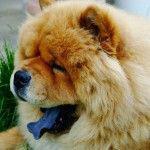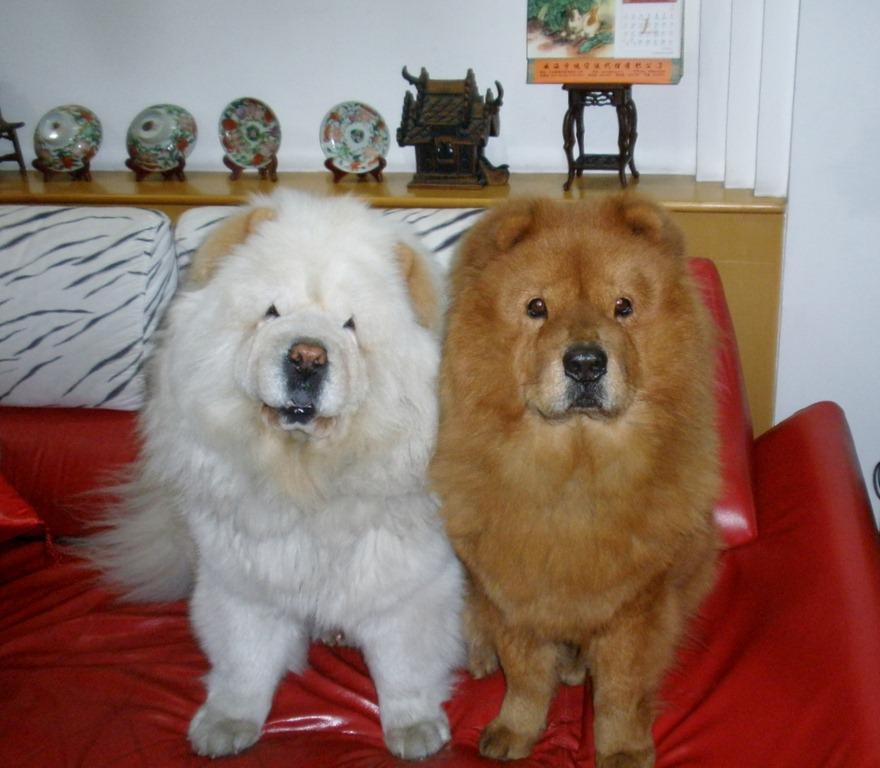The first image is the image on the left, the second image is the image on the right. Assess this claim about the two images: "Each image contains the same number of dogs, the left image includes a dog with its blue tongue out, and at least one image features a dog in a standing pose.". Correct or not? Answer yes or no. No. The first image is the image on the left, the second image is the image on the right. Evaluate the accuracy of this statement regarding the images: "There are two dogs in the right image.". Is it true? Answer yes or no. Yes. 